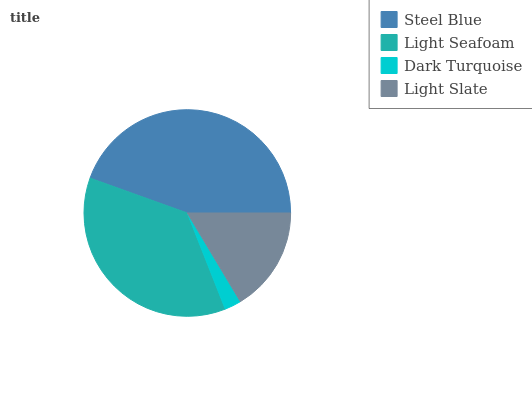Is Dark Turquoise the minimum?
Answer yes or no. Yes. Is Steel Blue the maximum?
Answer yes or no. Yes. Is Light Seafoam the minimum?
Answer yes or no. No. Is Light Seafoam the maximum?
Answer yes or no. No. Is Steel Blue greater than Light Seafoam?
Answer yes or no. Yes. Is Light Seafoam less than Steel Blue?
Answer yes or no. Yes. Is Light Seafoam greater than Steel Blue?
Answer yes or no. No. Is Steel Blue less than Light Seafoam?
Answer yes or no. No. Is Light Seafoam the high median?
Answer yes or no. Yes. Is Light Slate the low median?
Answer yes or no. Yes. Is Light Slate the high median?
Answer yes or no. No. Is Dark Turquoise the low median?
Answer yes or no. No. 